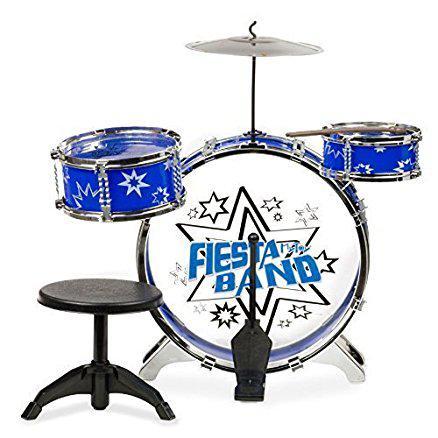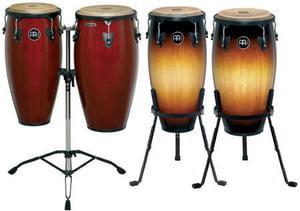The first image is the image on the left, the second image is the image on the right. Considering the images on both sides, is "There are four drum sticks." valid? Answer yes or no. No. 